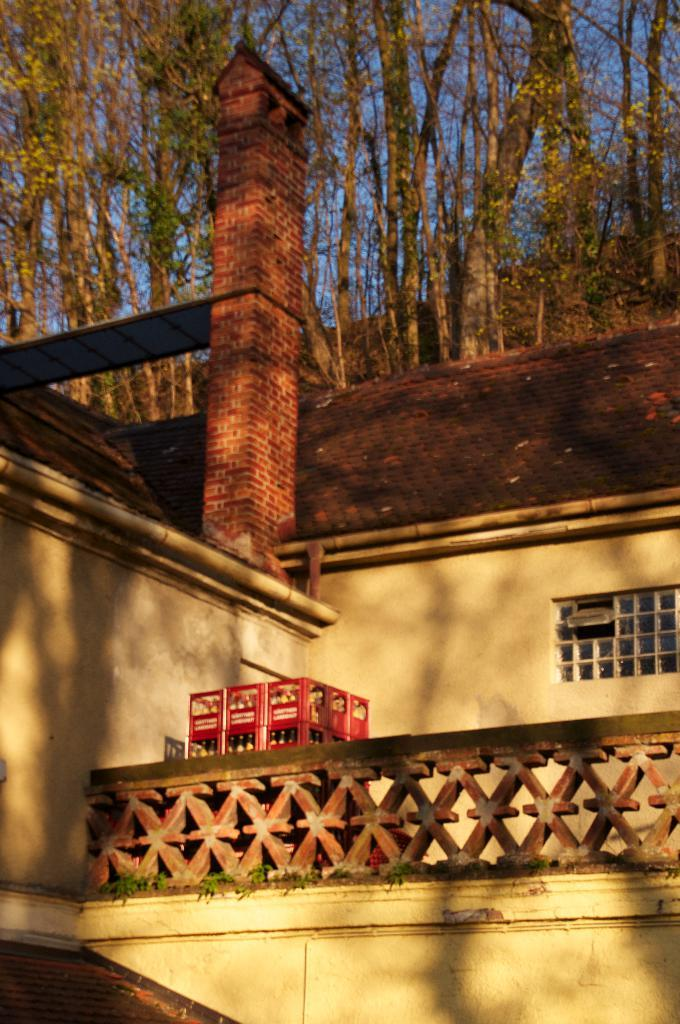What type of structure is present in the image? There is a building in the image. What can be seen inside the building? Baskets with bottles are visible in the image. What is the purpose of the fence in the image? The fence is likely used to define boundaries or provide security. What feature allows for a view of the outdoors from within the building? There is a window in the image. What type of natural environment is visible in the background of the image? Trees and the sky are visible in the background of the image. How does the car move around in the image? There is no car present in the image. What is the birth rate of the trees in the background? The image does not provide information about the age or growth rate of the trees, so it is impossible to determine their birth rate. 